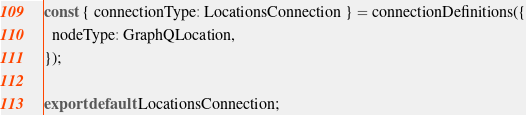<code> <loc_0><loc_0><loc_500><loc_500><_JavaScript_>const { connectionType: LocationsConnection } = connectionDefinitions({
  nodeType: GraphQLocation,
});

export default LocationsConnection;
</code> 